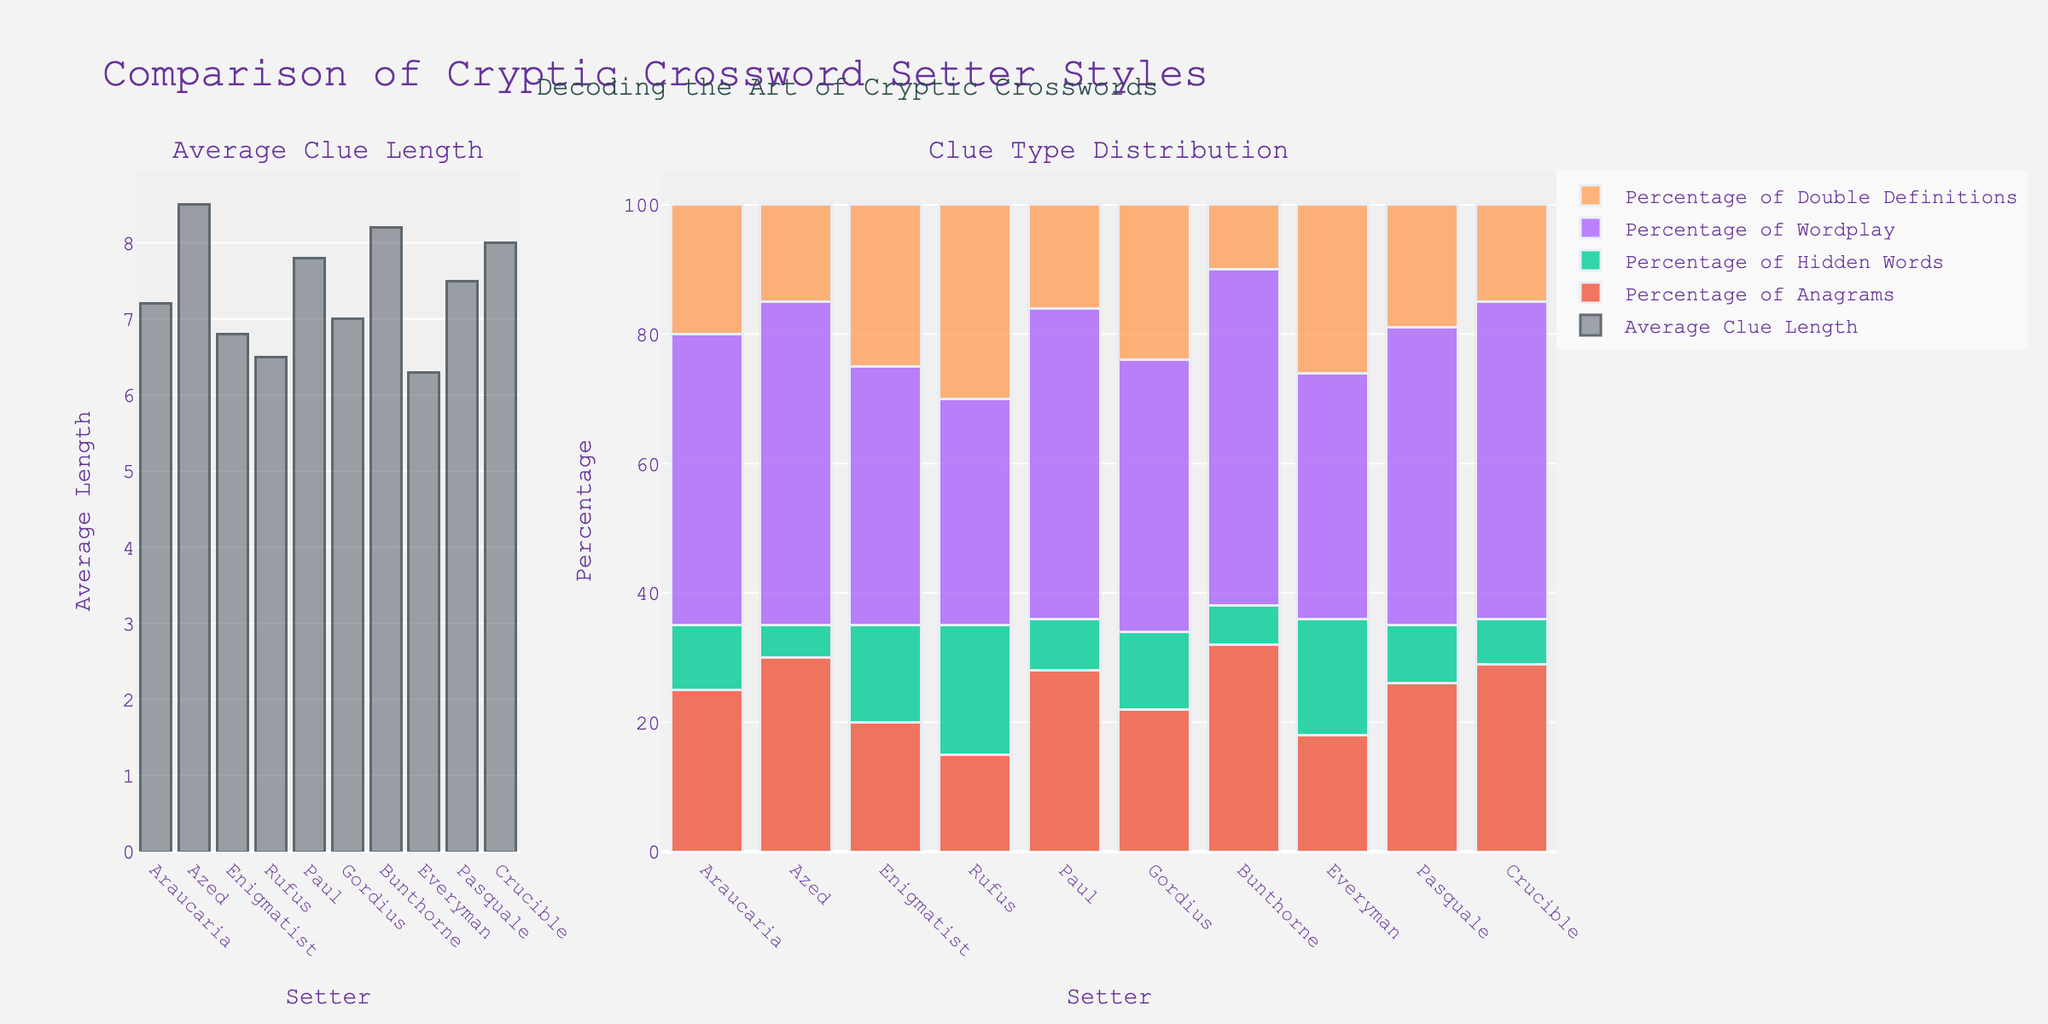Which setter has the longest average clue length? Look at the bar in the "Average Clue Length" plot, the tallest bar corresponds to Azed with a value of 8.5.
Answer: Azed Which setter has the highest percentage of wordplay clues? In the "Clue Type Distribution" plot, observe the "Percentage of Wordplay" category and identify the tallest bar, which belongs to Bunthorne with 52%.
Answer: Bunthorne How does the average clue length of Enigmatist compare with Everyman? In the "Average Clue Length" plot, compare the height of the bars for Enigmatist (6.8) and Everyman (6.3). Enigmatist has a higher average clue length than Everyman.
Answer: Enigmatist has a higher average clue length Which setter has the lowest percentage of double definitions? In the "Clue Type Distribution" plot, under the "Percentage of Double Definitions" category, Bunthorne's bar is the shortest at 10%.
Answer: Bunthorne Calculate the difference in the percentage of anagrams between Paul and Azed. From the "Clue Type Distribution" plot, note Paul's percentage of anagrams (28%) and Azed's (30%). Subtract Paul's percentage from Azed's: 30 - 28 = 2.
Answer: 2 What is the total percentage of hidden words and wordplay clues for Everyman? Add the percentages from the "Clue Type Distribution" plot for Everyman: Hidden Words (18%) + Wordplay (38%) = 56%.
Answer: 56% Compare the average clue lengths of Pasquale and Crucible. Which setter has a longer average clue length, and by how much? In the "Average Clue Length" plot, Pasquale's bar is at 7.5 and Crucible's at 8.0. Subtract Pasquale's value from Crucible's: 8.0 - 7.5 = 0.5. Crucible has a longer average clue length by 0.5.
Answer: Crucible by 0.5 Which setter has the highest combined percentage of anagrams and hidden words, and what is that total percentage? Calculate the sum for each setter. For Bunthorne: Anagrams (32%) + Hidden Words (6%) = 38%. Other setters have lower sums.
Answer: Bunthorne with 38% What is the difference in the percentage of double definitions between Rufus and Gordius? From the "Clue Type Distribution" plot, note Rufus' percentage of double definitions (30%) and Gordius' (24%). Subtract Gordius' percentage from Rufus': 30 - 24 = 6.
Answer: 6 Which setter has the most balanced distribution among the clue types (anagrams, hidden words, wordplay, double definitions)? Look for a setter whose bars in the "Clue Type Distribution" plot are relatively even in height compared to others. Rufus has relatively balanced percentages: Anagrams (15%), Hidden Words (20%), Wordplay (35%), Double Definitions (30%).
Answer: Rufus 